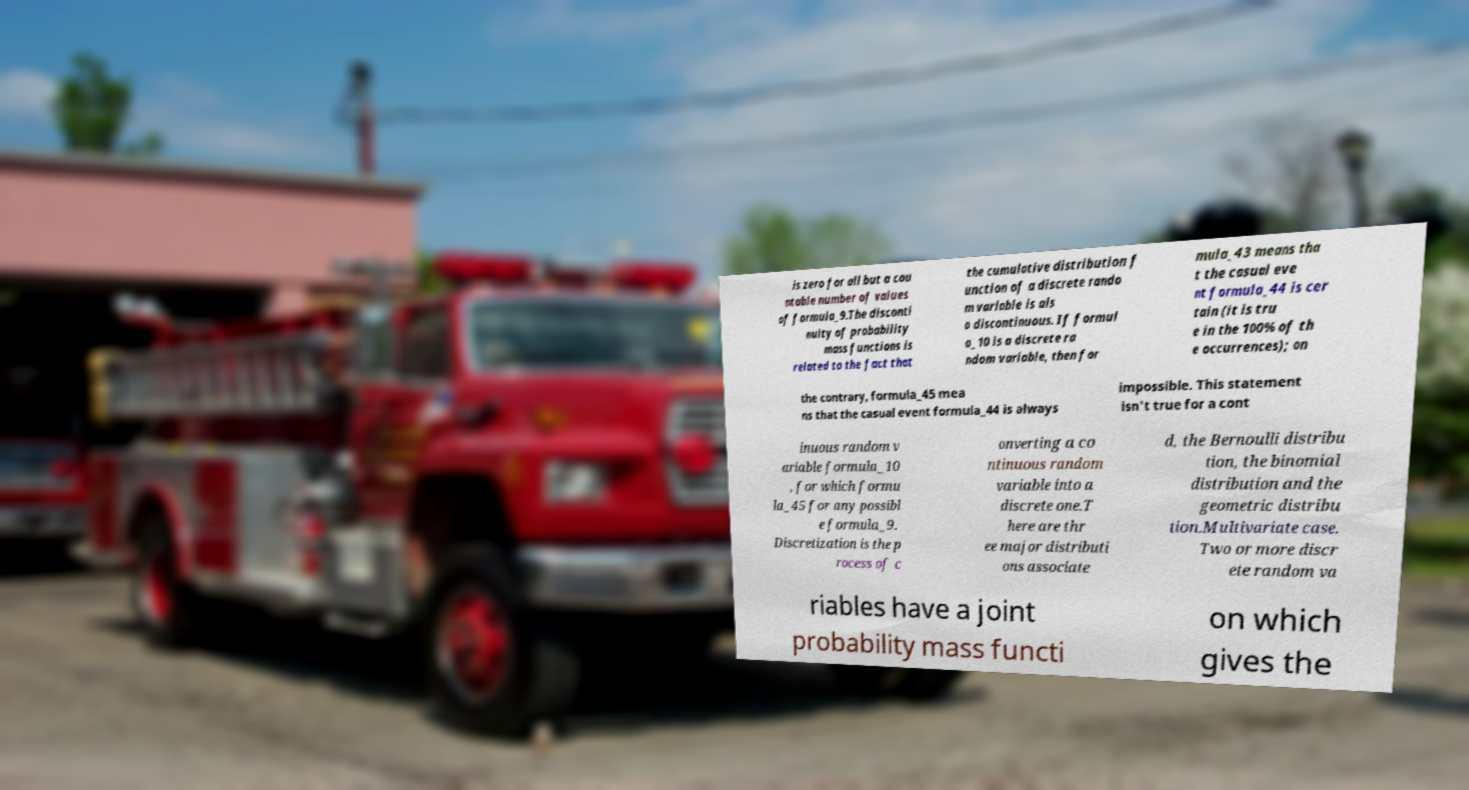Can you accurately transcribe the text from the provided image for me? is zero for all but a cou ntable number of values of formula_9.The disconti nuity of probability mass functions is related to the fact that the cumulative distribution f unction of a discrete rando m variable is als o discontinuous. If formul a_10 is a discrete ra ndom variable, then for mula_43 means tha t the casual eve nt formula_44 is cer tain (it is tru e in the 100% of th e occurrences); on the contrary, formula_45 mea ns that the casual event formula_44 is always impossible. This statement isn't true for a cont inuous random v ariable formula_10 , for which formu la_45 for any possibl e formula_9. Discretization is the p rocess of c onverting a co ntinuous random variable into a discrete one.T here are thr ee major distributi ons associate d, the Bernoulli distribu tion, the binomial distribution and the geometric distribu tion.Multivariate case. Two or more discr ete random va riables have a joint probability mass functi on which gives the 